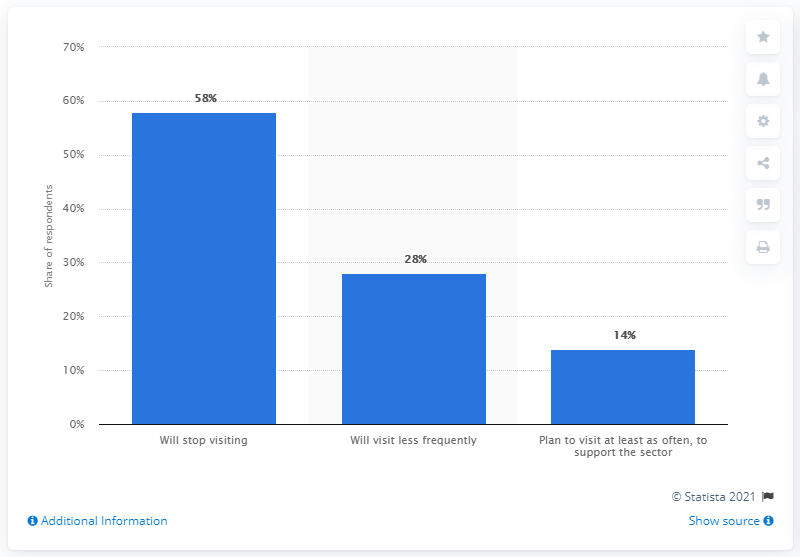Outline some significant characteristics in this image. According to a survey, a significant percentage of consumers, 58%, stated that they would stop visiting bars, pubs, and restaurants. 